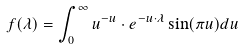Convert formula to latex. <formula><loc_0><loc_0><loc_500><loc_500>f ( \lambda ) = \int _ { 0 } ^ { \infty } u ^ { - u } \cdot e ^ { - u \cdot \lambda } \sin ( \pi u ) d u</formula> 